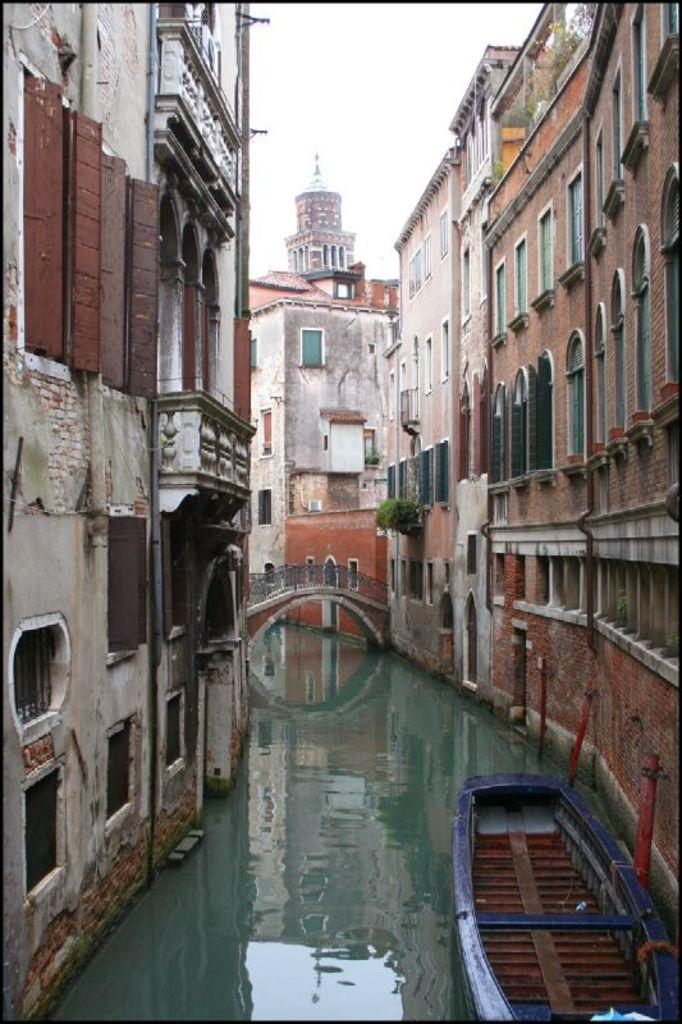What type of structures can be seen in the image? There are buildings in the image. What natural element is visible in the image? There is water visible in the image. What mode of transportation is present in the image? There is a boat in the image. What architectural feature is present in the image? There is a bridge in the image. What part of the natural environment is visible in the image? The sky is visible in the image. How many ducks are swimming in the water in the image? There are no ducks present in the image; it features a boat, buildings, a bridge, and water. Can you tell me the color of the person's shirt in the image? There is no person present in the image, so it is not possible to determine the color of their shirt. 